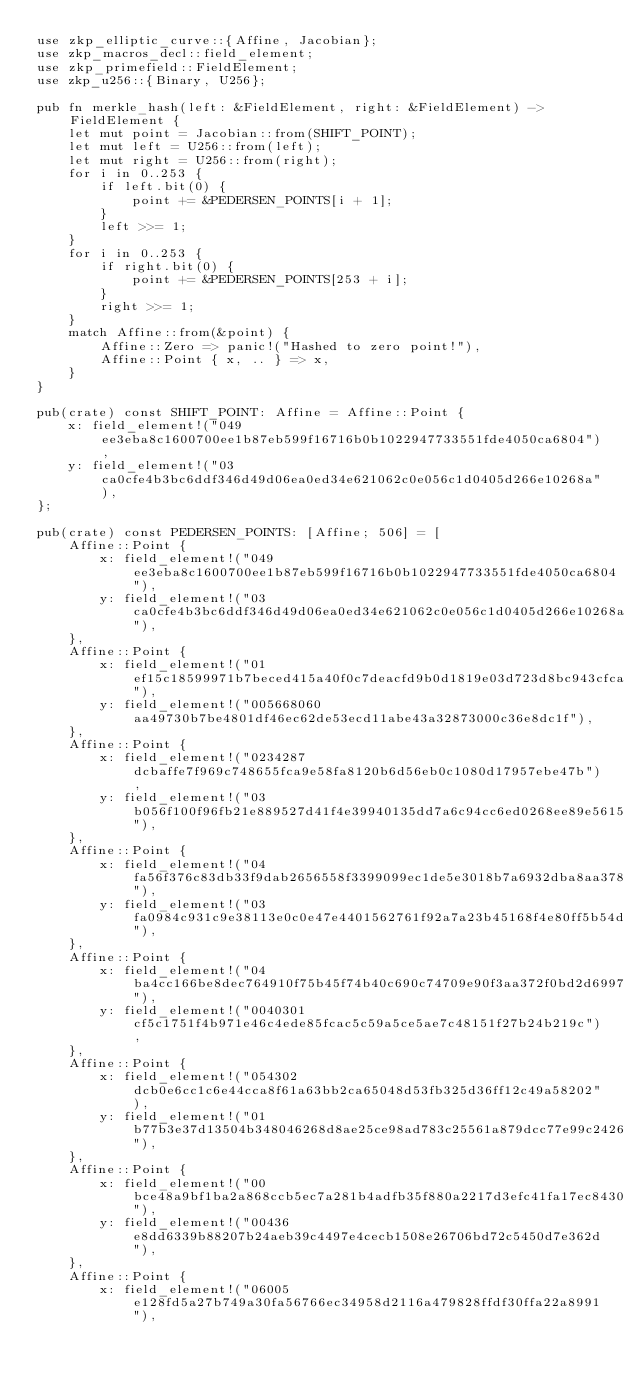<code> <loc_0><loc_0><loc_500><loc_500><_Rust_>use zkp_elliptic_curve::{Affine, Jacobian};
use zkp_macros_decl::field_element;
use zkp_primefield::FieldElement;
use zkp_u256::{Binary, U256};

pub fn merkle_hash(left: &FieldElement, right: &FieldElement) -> FieldElement {
    let mut point = Jacobian::from(SHIFT_POINT);
    let mut left = U256::from(left);
    let mut right = U256::from(right);
    for i in 0..253 {
        if left.bit(0) {
            point += &PEDERSEN_POINTS[i + 1];
        }
        left >>= 1;
    }
    for i in 0..253 {
        if right.bit(0) {
            point += &PEDERSEN_POINTS[253 + i];
        }
        right >>= 1;
    }
    match Affine::from(&point) {
        Affine::Zero => panic!("Hashed to zero point!"),
        Affine::Point { x, .. } => x,
    }
}

pub(crate) const SHIFT_POINT: Affine = Affine::Point {
    x: field_element!("049ee3eba8c1600700ee1b87eb599f16716b0b1022947733551fde4050ca6804"),
    y: field_element!("03ca0cfe4b3bc6ddf346d49d06ea0ed34e621062c0e056c1d0405d266e10268a"),
};

pub(crate) const PEDERSEN_POINTS: [Affine; 506] = [
    Affine::Point {
        x: field_element!("049ee3eba8c1600700ee1b87eb599f16716b0b1022947733551fde4050ca6804"),
        y: field_element!("03ca0cfe4b3bc6ddf346d49d06ea0ed34e621062c0e056c1d0405d266e10268a"),
    },
    Affine::Point {
        x: field_element!("01ef15c18599971b7beced415a40f0c7deacfd9b0d1819e03d723d8bc943cfca"),
        y: field_element!("005668060aa49730b7be4801df46ec62de53ecd11abe43a32873000c36e8dc1f"),
    },
    Affine::Point {
        x: field_element!("0234287dcbaffe7f969c748655fca9e58fa8120b6d56eb0c1080d17957ebe47b"),
        y: field_element!("03b056f100f96fb21e889527d41f4e39940135dd7a6c94cc6ed0268ee89e5615"),
    },
    Affine::Point {
        x: field_element!("04fa56f376c83db33f9dab2656558f3399099ec1de5e3018b7a6932dba8aa378"),
        y: field_element!("03fa0984c931c9e38113e0c0e47e4401562761f92a7a23b45168f4e80ff5b54d"),
    },
    Affine::Point {
        x: field_element!("04ba4cc166be8dec764910f75b45f74b40c690c74709e90f3aa372f0bd2d6997"),
        y: field_element!("0040301cf5c1751f4b971e46c4ede85fcac5c59a5ce5ae7c48151f27b24b219c"),
    },
    Affine::Point {
        x: field_element!("054302dcb0e6cc1c6e44cca8f61a63bb2ca65048d53fb325d36ff12c49a58202"),
        y: field_element!("01b77b3e37d13504b348046268d8ae25ce98ad783c25561a879dcc77e99c2426"),
    },
    Affine::Point {
        x: field_element!("00bce48a9bf1ba2a868ccb5ec7a281b4adfb35f880a2217d3efc41fa17ec8430"),
        y: field_element!("00436e8dd6339b88207b24aeb39c4497e4cecb1508e26706bd72c5450d7e362d"),
    },
    Affine::Point {
        x: field_element!("06005e128fd5a27b749a30fa56766ec34958d2116a479828ffdf30ffa22a8991"),</code> 